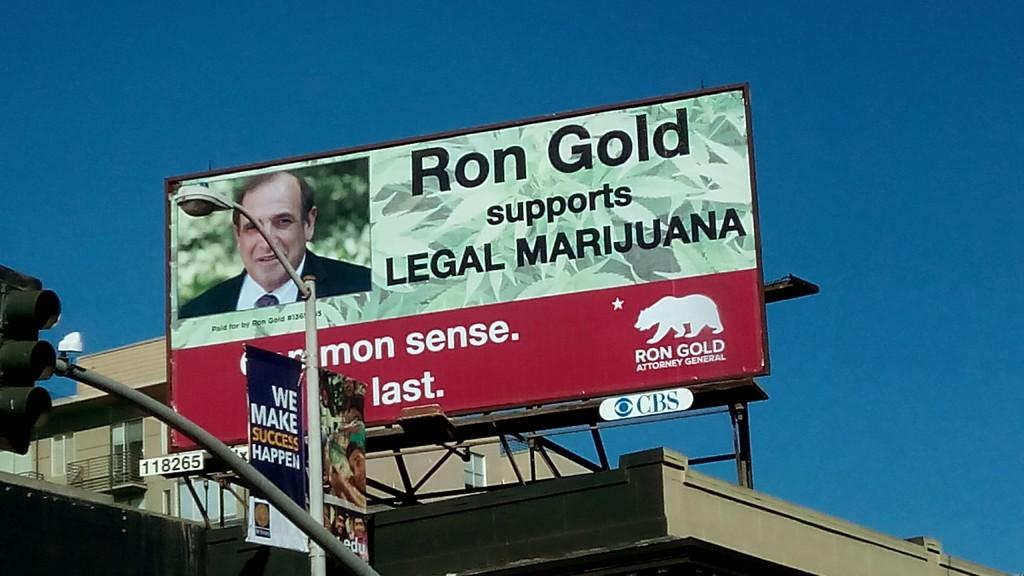<image>
Summarize the visual content of the image. Billboard on a building saying Ron Gold supports Legal Marijuana. 